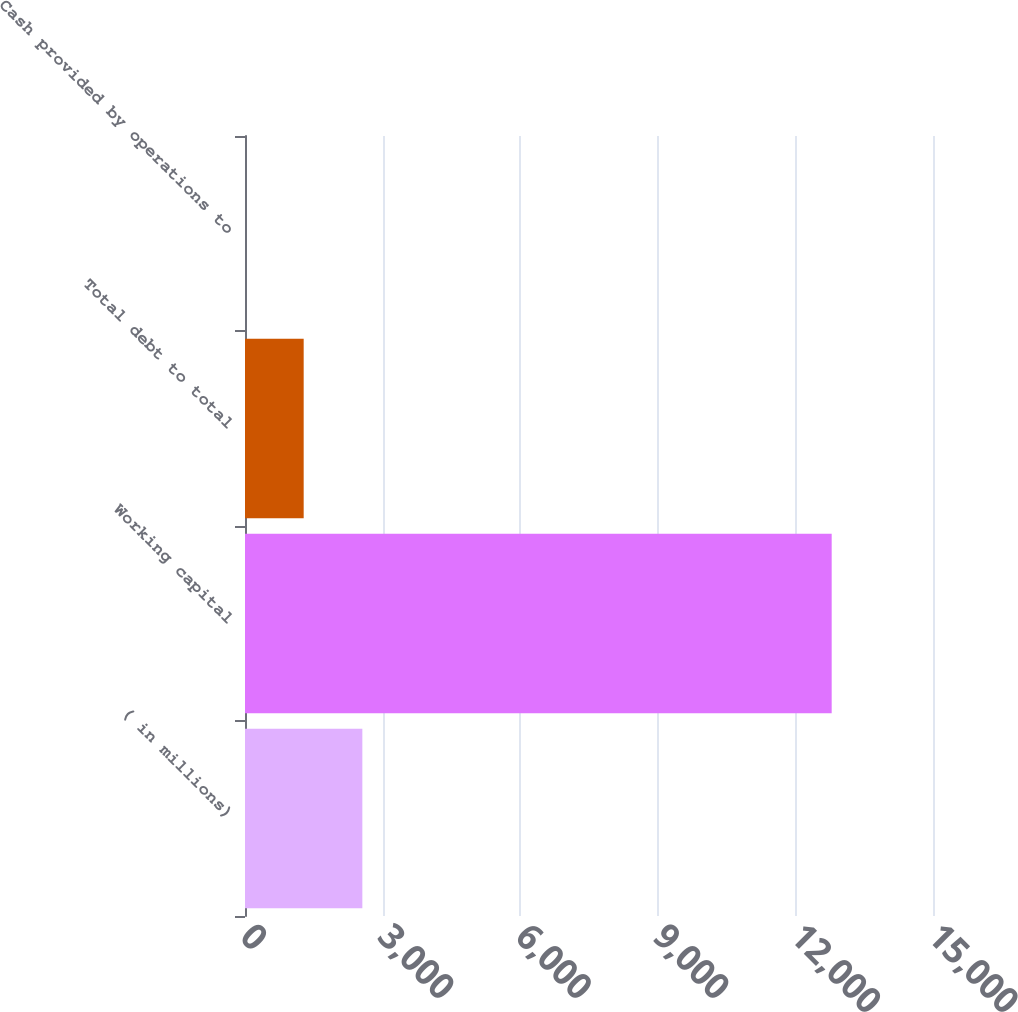Convert chart. <chart><loc_0><loc_0><loc_500><loc_500><bar_chart><fcel>( in millions)<fcel>Working capital<fcel>Total debt to total<fcel>Cash provided by operations to<nl><fcel>2558.37<fcel>12791<fcel>1279.29<fcel>0.21<nl></chart> 